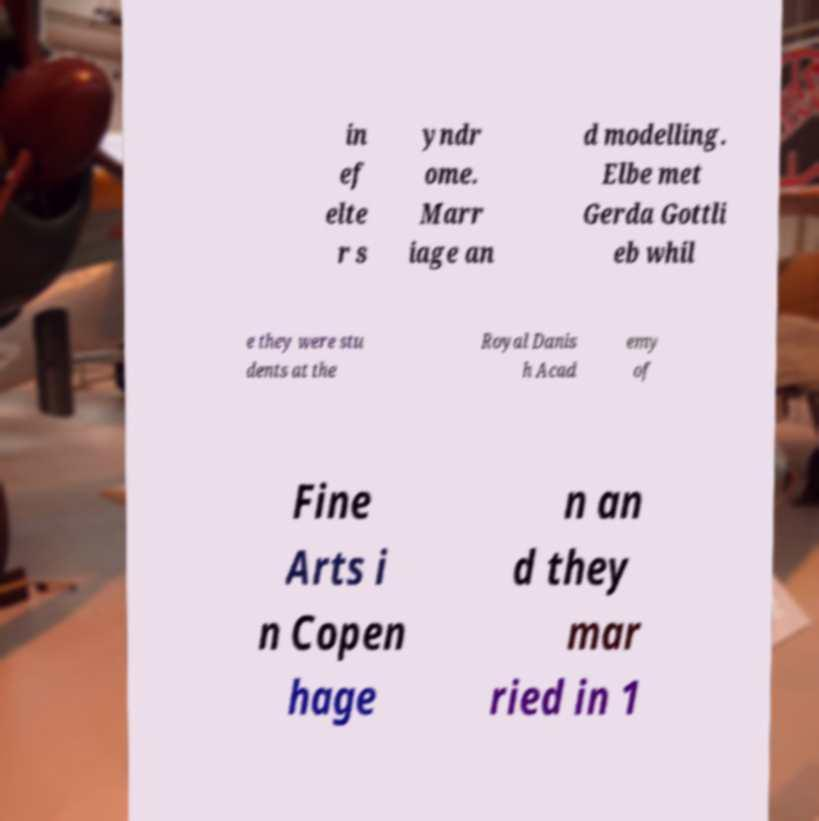Could you extract and type out the text from this image? in ef elte r s yndr ome. Marr iage an d modelling. Elbe met Gerda Gottli eb whil e they were stu dents at the Royal Danis h Acad emy of Fine Arts i n Copen hage n an d they mar ried in 1 